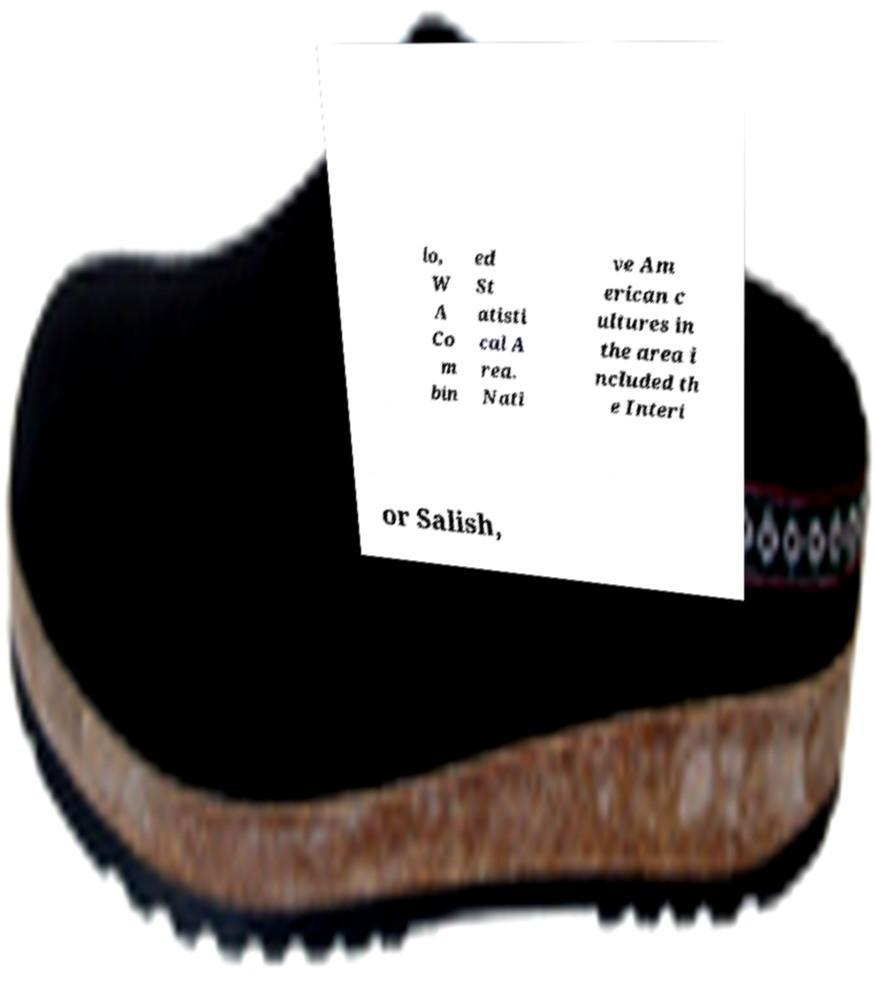Could you extract and type out the text from this image? lo, W A Co m bin ed St atisti cal A rea. Nati ve Am erican c ultures in the area i ncluded th e Interi or Salish, 